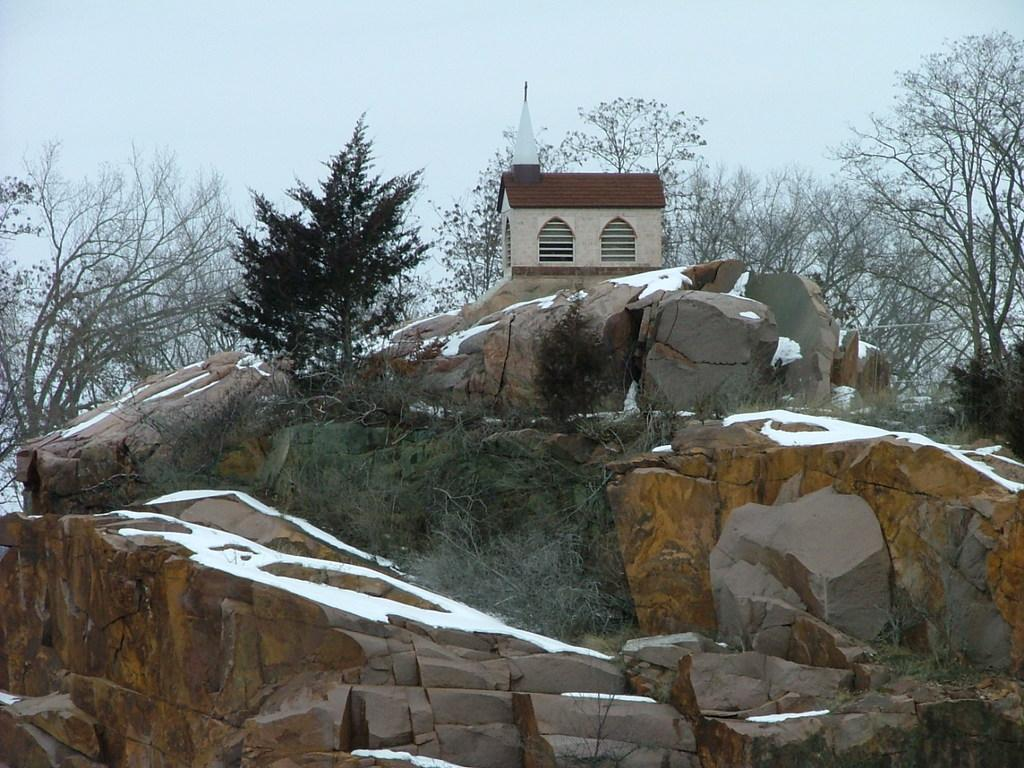What type of structure is visible in the image? There is a house in the image. What natural elements are present in the image? There are many trees and plants in the image. What part of the natural environment is visible in the image? The sky is visible in the image. Can you describe any other objects or features in the image? There is a rock in the image. Where is the lunchroom located in the image? There is no lunchroom present in the image. What type of activity is taking place in the image? The image does not depict any specific activity; it shows a house, trees, plants, the sky, and a rock. 